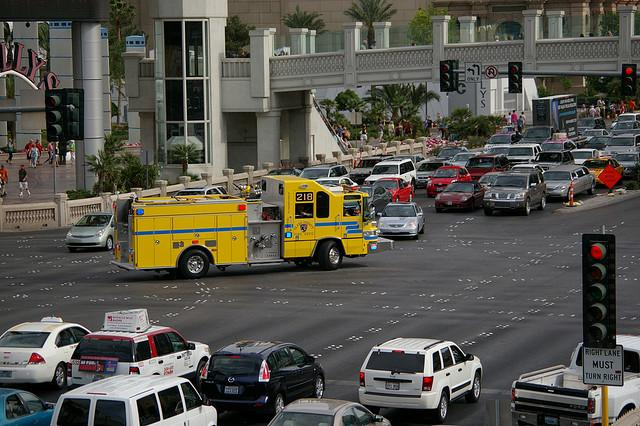Why are all the other cars letting the yellow truck go?

Choices:
A) respect
B) scared
C) emergency
D) no reason emergency 